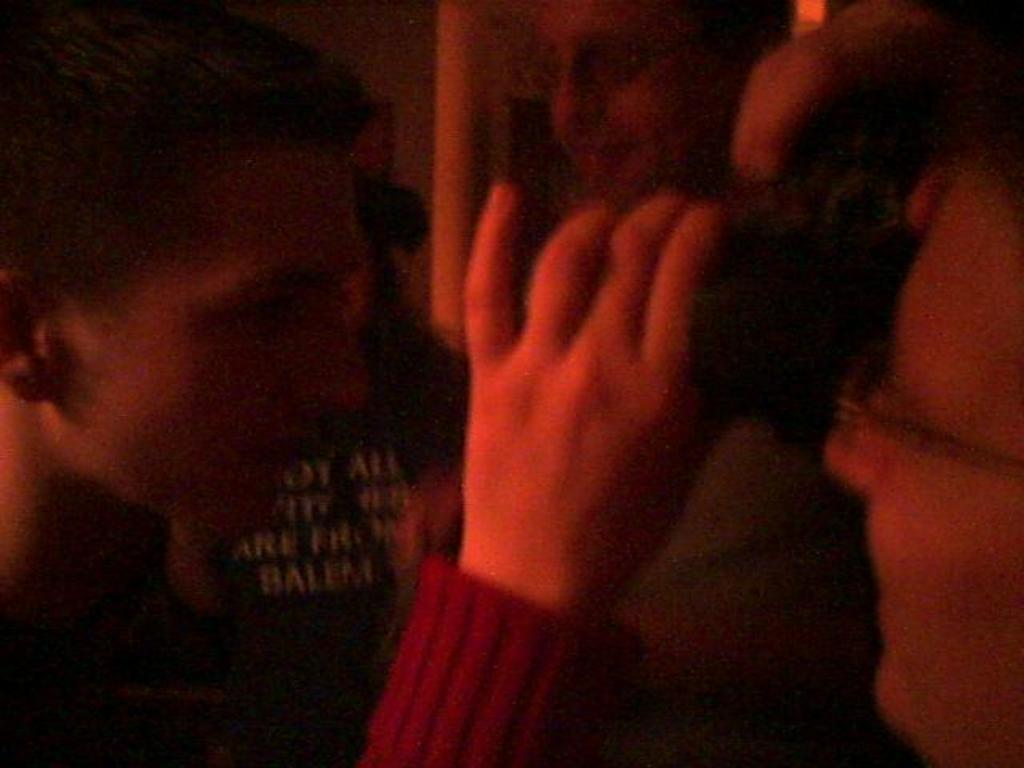How many people are in the image? There is a group of persons in the image. Can you describe any specific details about the people in the image? There is text visible on a person's shirt in the background of the image. What type of tin can be seen in the image? There is no tin present in the image. Is there a scarecrow visible in the image? There is no scarecrow present in the image. 